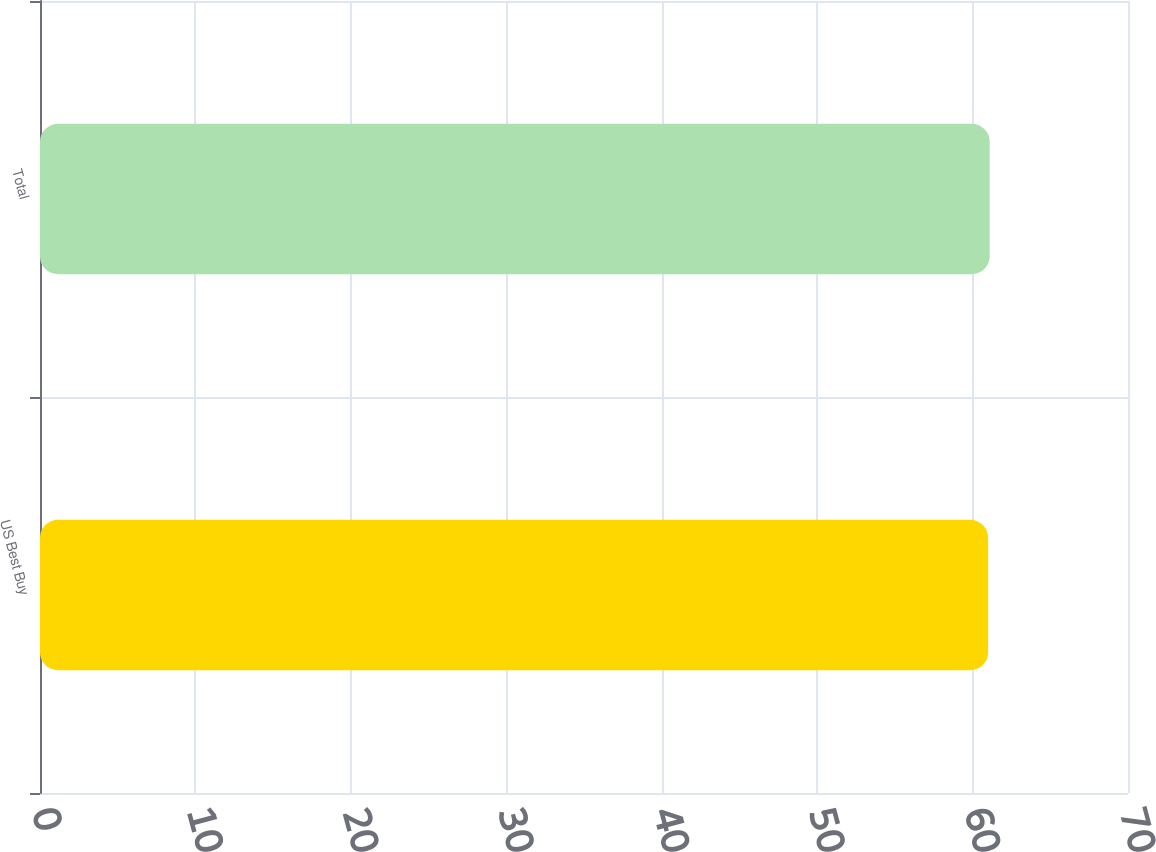Convert chart to OTSL. <chart><loc_0><loc_0><loc_500><loc_500><bar_chart><fcel>US Best Buy<fcel>Total<nl><fcel>61<fcel>61.1<nl></chart> 